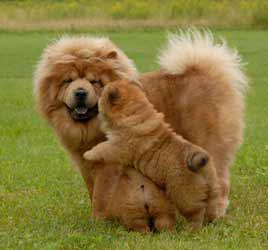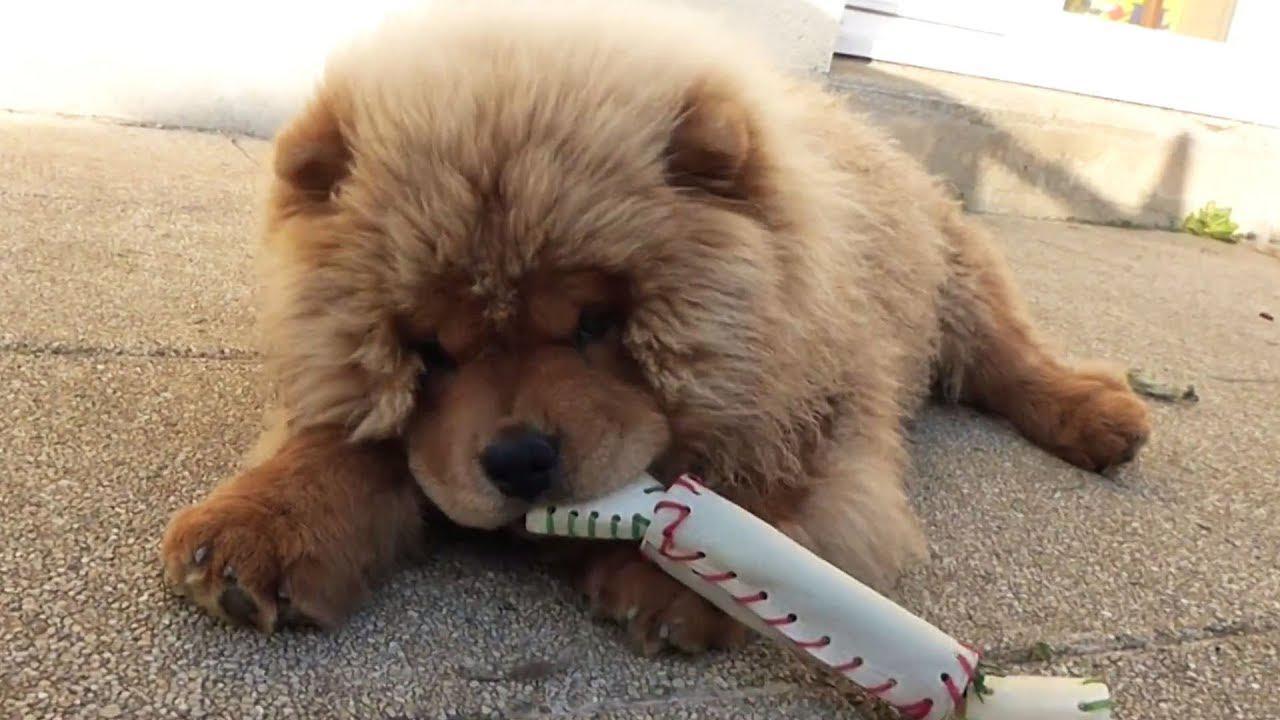The first image is the image on the left, the second image is the image on the right. Evaluate the accuracy of this statement regarding the images: "The image on the right has one dog with a toy in its mouth.". Is it true? Answer yes or no. Yes. The first image is the image on the left, the second image is the image on the right. Analyze the images presented: Is the assertion "One of the dogs has something in its mouth." valid? Answer yes or no. Yes. 